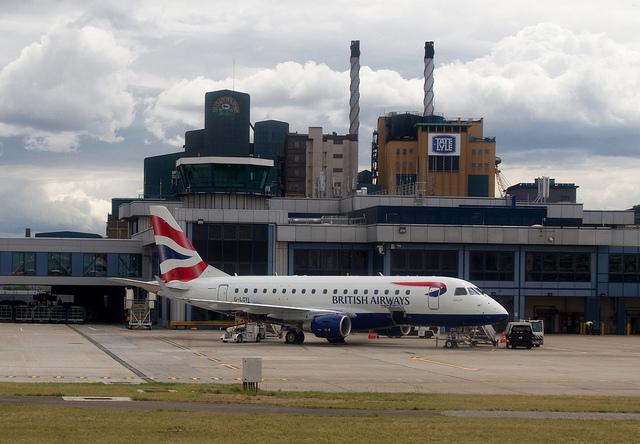Is it a sunny day?
Be succinct. No. Who owns this plane?
Be succinct. British airways. How many smoke stacks are in the background?
Give a very brief answer. 2. 